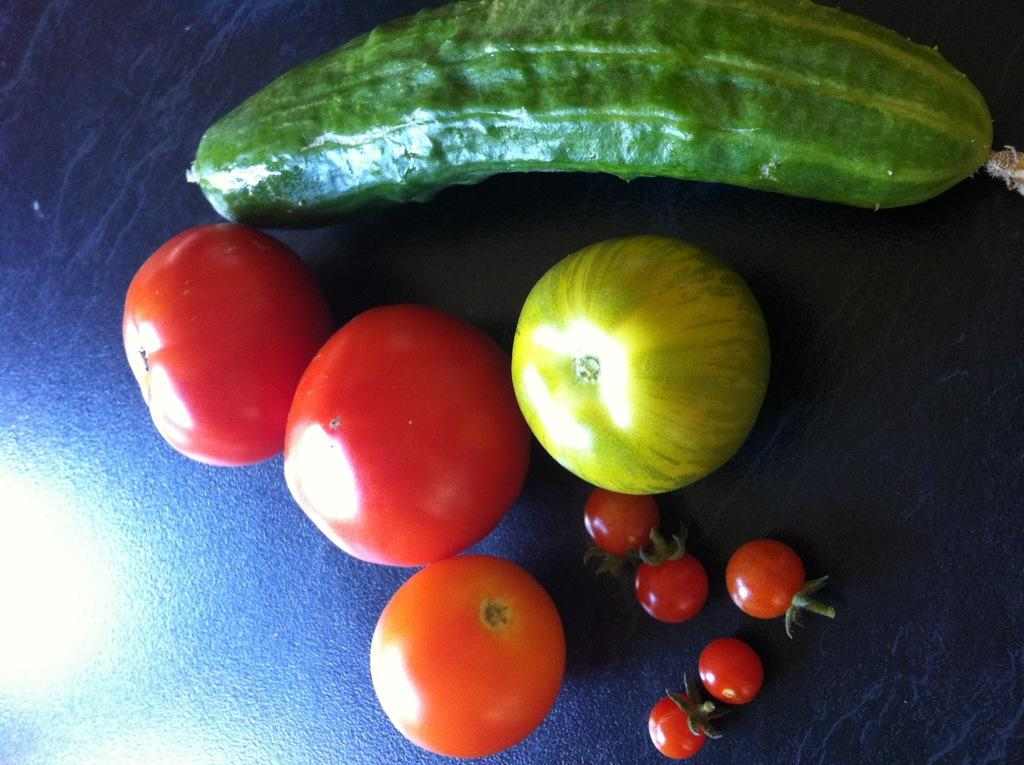What types of food items can be seen in the image? There are fruits and vegetables in the image. Where are the fruits and vegetables located? The fruits and vegetables are on a surface. What type of berry is featured in the art piece in the image? There is no art piece or berry present in the image; it features fruits and vegetables on a surface. 